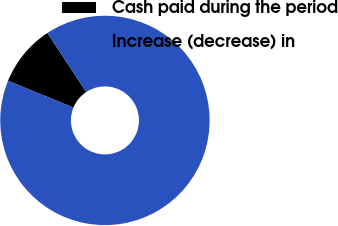<chart> <loc_0><loc_0><loc_500><loc_500><pie_chart><fcel>Cash paid during the period<fcel>Increase (decrease) in<nl><fcel>9.56%<fcel>90.44%<nl></chart> 